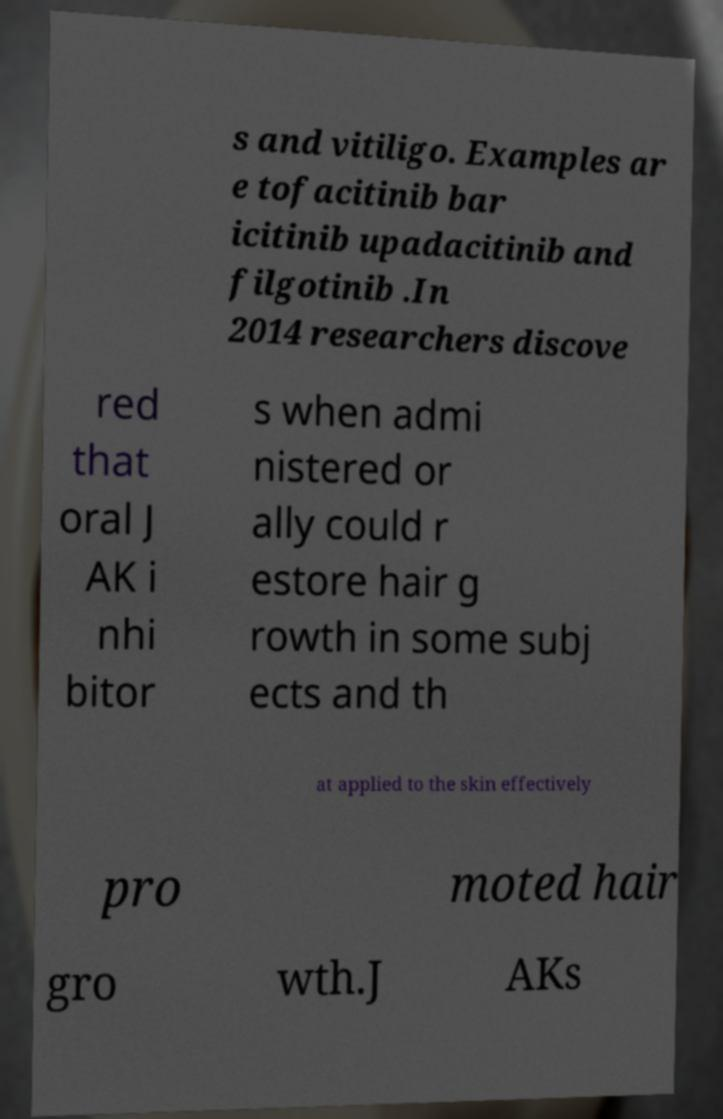There's text embedded in this image that I need extracted. Can you transcribe it verbatim? s and vitiligo. Examples ar e tofacitinib bar icitinib upadacitinib and filgotinib .In 2014 researchers discove red that oral J AK i nhi bitor s when admi nistered or ally could r estore hair g rowth in some subj ects and th at applied to the skin effectively pro moted hair gro wth.J AKs 